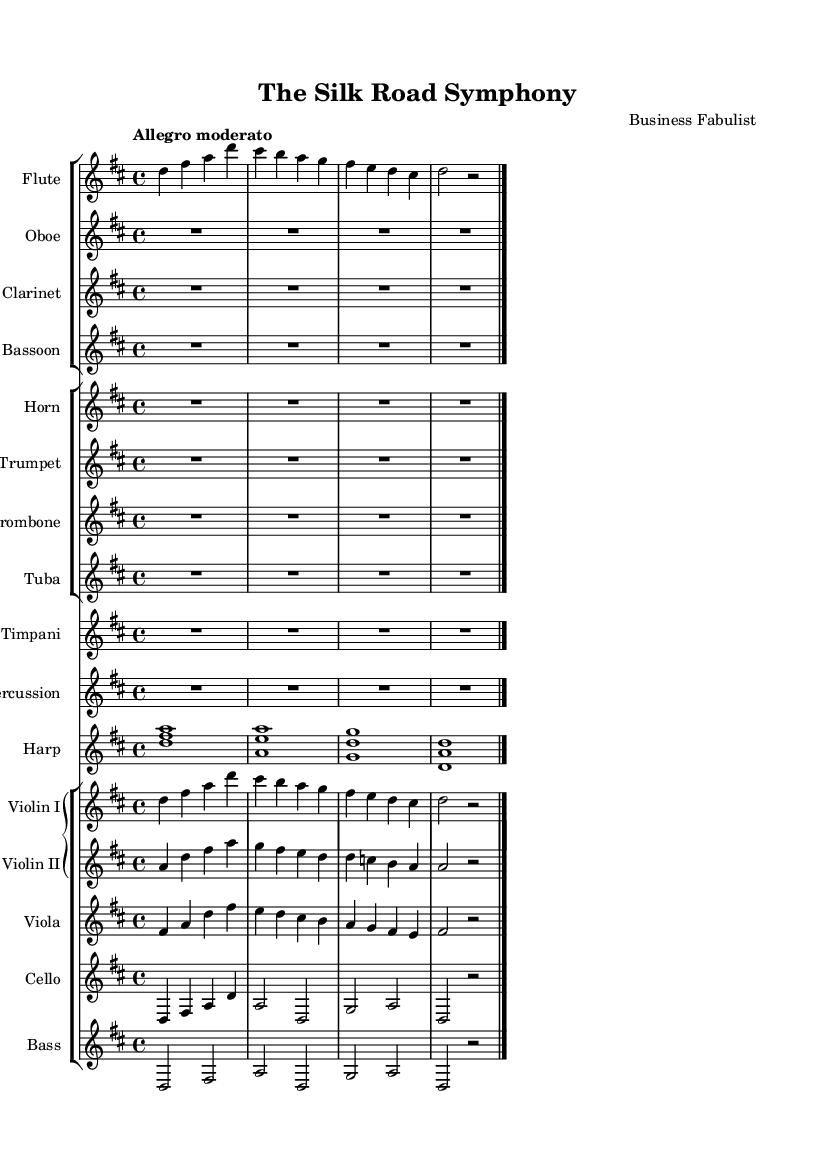What is the key signature of this music? The key signature is indicated at the beginning of the score, showing two sharps, which corresponds to D major.
Answer: D major What is the time signature of this piece? The time signature is indicated right after the key signature, displayed as four beats per measure, which is denoted by 4/4.
Answer: 4/4 What is the tempo marking for this symphony? The tempo marking is specified in quotation marks at the start of the score, indicating a moderate speed, labeled as "Allegro moderato."
Answer: Allegro moderato How many unique instruments are featured in this symphony? By counting the different staves, the score displays a total of 12 unique instruments, including wind, brass, percussion, harp, and strings.
Answer: 12 What is the harmony instrument in this piece? The harp is the only instrument explicitly playing harmony notes, as shown with chords notated on its staff.
Answer: Harp What sections are indicated in the orchestration? The score organizes the instruments into multiple staff groups: woodwinds, brass, percussion, harp, and strings, indicating distinct sections for orchestration.
Answer: Woodwinds, Brass, Percussion, Harp, Strings How many measures are present in the first section for violins? In looking at the violin I and II parts, there are four measures present in the first section, as denoted by the bar lines.
Answer: 4 